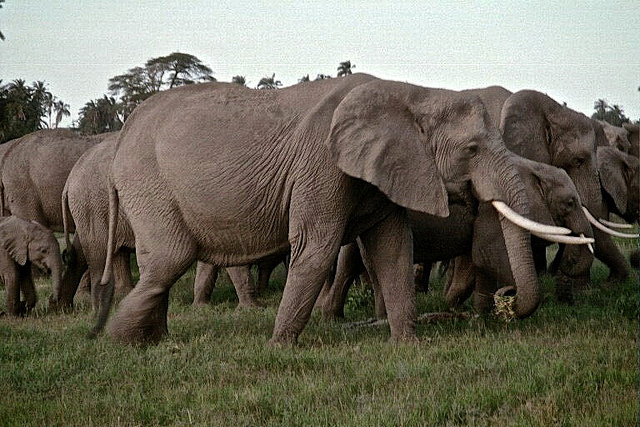<image>Why is the picture taken far away from the elephant? It is ambiguous why the picture is taken far away from the elephant. It could be for reasons such as safety, due to the elephant's size, or to avoid upsetting the animal. Why is the picture taken far away from the elephant? I don't know why the picture is taken far away from the elephant. It can be due to safety reasons or to avoid scaring them. 